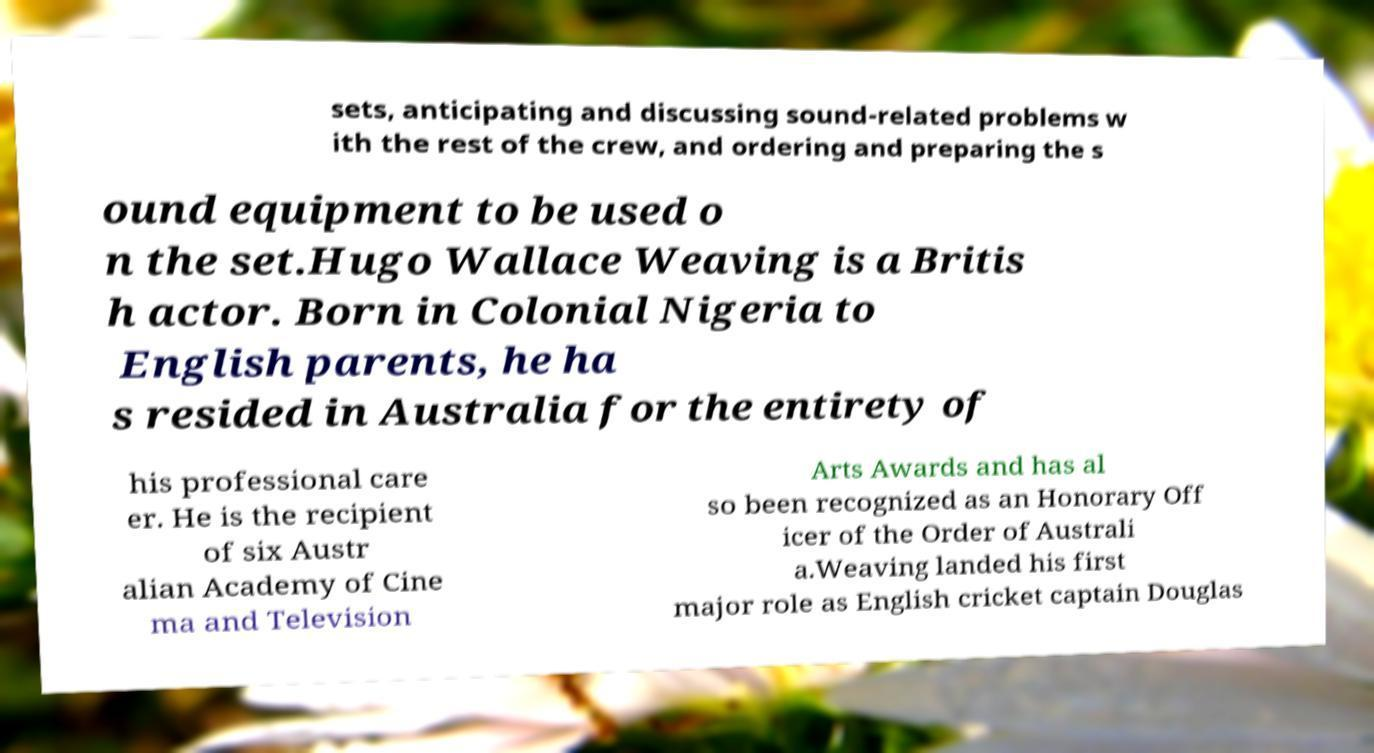Could you assist in decoding the text presented in this image and type it out clearly? sets, anticipating and discussing sound-related problems w ith the rest of the crew, and ordering and preparing the s ound equipment to be used o n the set.Hugo Wallace Weaving is a Britis h actor. Born in Colonial Nigeria to English parents, he ha s resided in Australia for the entirety of his professional care er. He is the recipient of six Austr alian Academy of Cine ma and Television Arts Awards and has al so been recognized as an Honorary Off icer of the Order of Australi a.Weaving landed his first major role as English cricket captain Douglas 